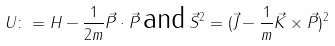Convert formula to latex. <formula><loc_0><loc_0><loc_500><loc_500>U \colon = H - \frac { 1 } { 2 m } \vec { P } \cdot \vec { P } \, \text {and} \, \vec { S } ^ { 2 } = ( \vec { J } - \frac { 1 } { m } \vec { K } \times \vec { P } ) ^ { 2 }</formula> 